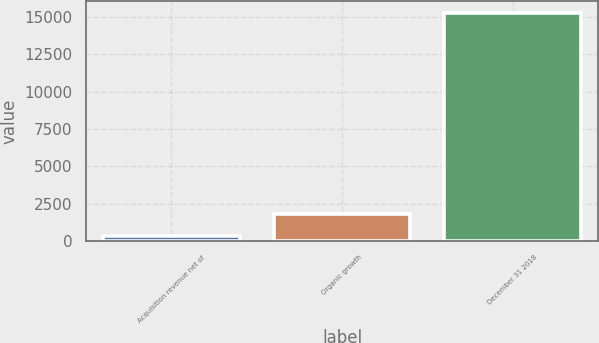Convert chart to OTSL. <chart><loc_0><loc_0><loc_500><loc_500><bar_chart><fcel>Acquisition revenue net of<fcel>Organic growth<fcel>December 31 2018<nl><fcel>326.6<fcel>1822.96<fcel>15290.2<nl></chart> 